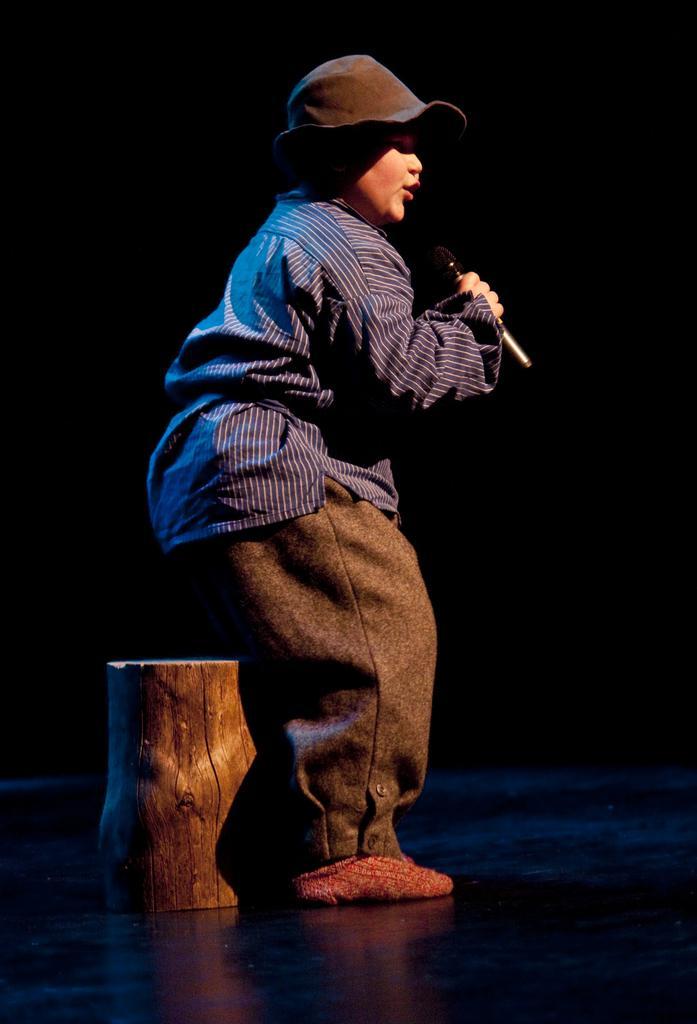Could you give a brief overview of what you see in this image? I can see a boy holding a mike and singing a song. He is wearing a hat. And I think this is a wood stool to sit. 